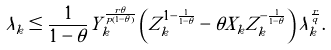Convert formula to latex. <formula><loc_0><loc_0><loc_500><loc_500>\lambda _ { k } \leq \frac { 1 } { 1 - \theta } Y _ { k } ^ { \frac { r \theta } { p ( 1 - \theta ) } } \left ( Z _ { k } ^ { 1 - \frac { 1 } { 1 - \theta } } - \theta X _ { k } Z _ { k } ^ { - \frac { 1 } { 1 - \theta } } \right ) \tilde { \lambda } _ { k } ^ { \frac { r } { q } } .</formula> 